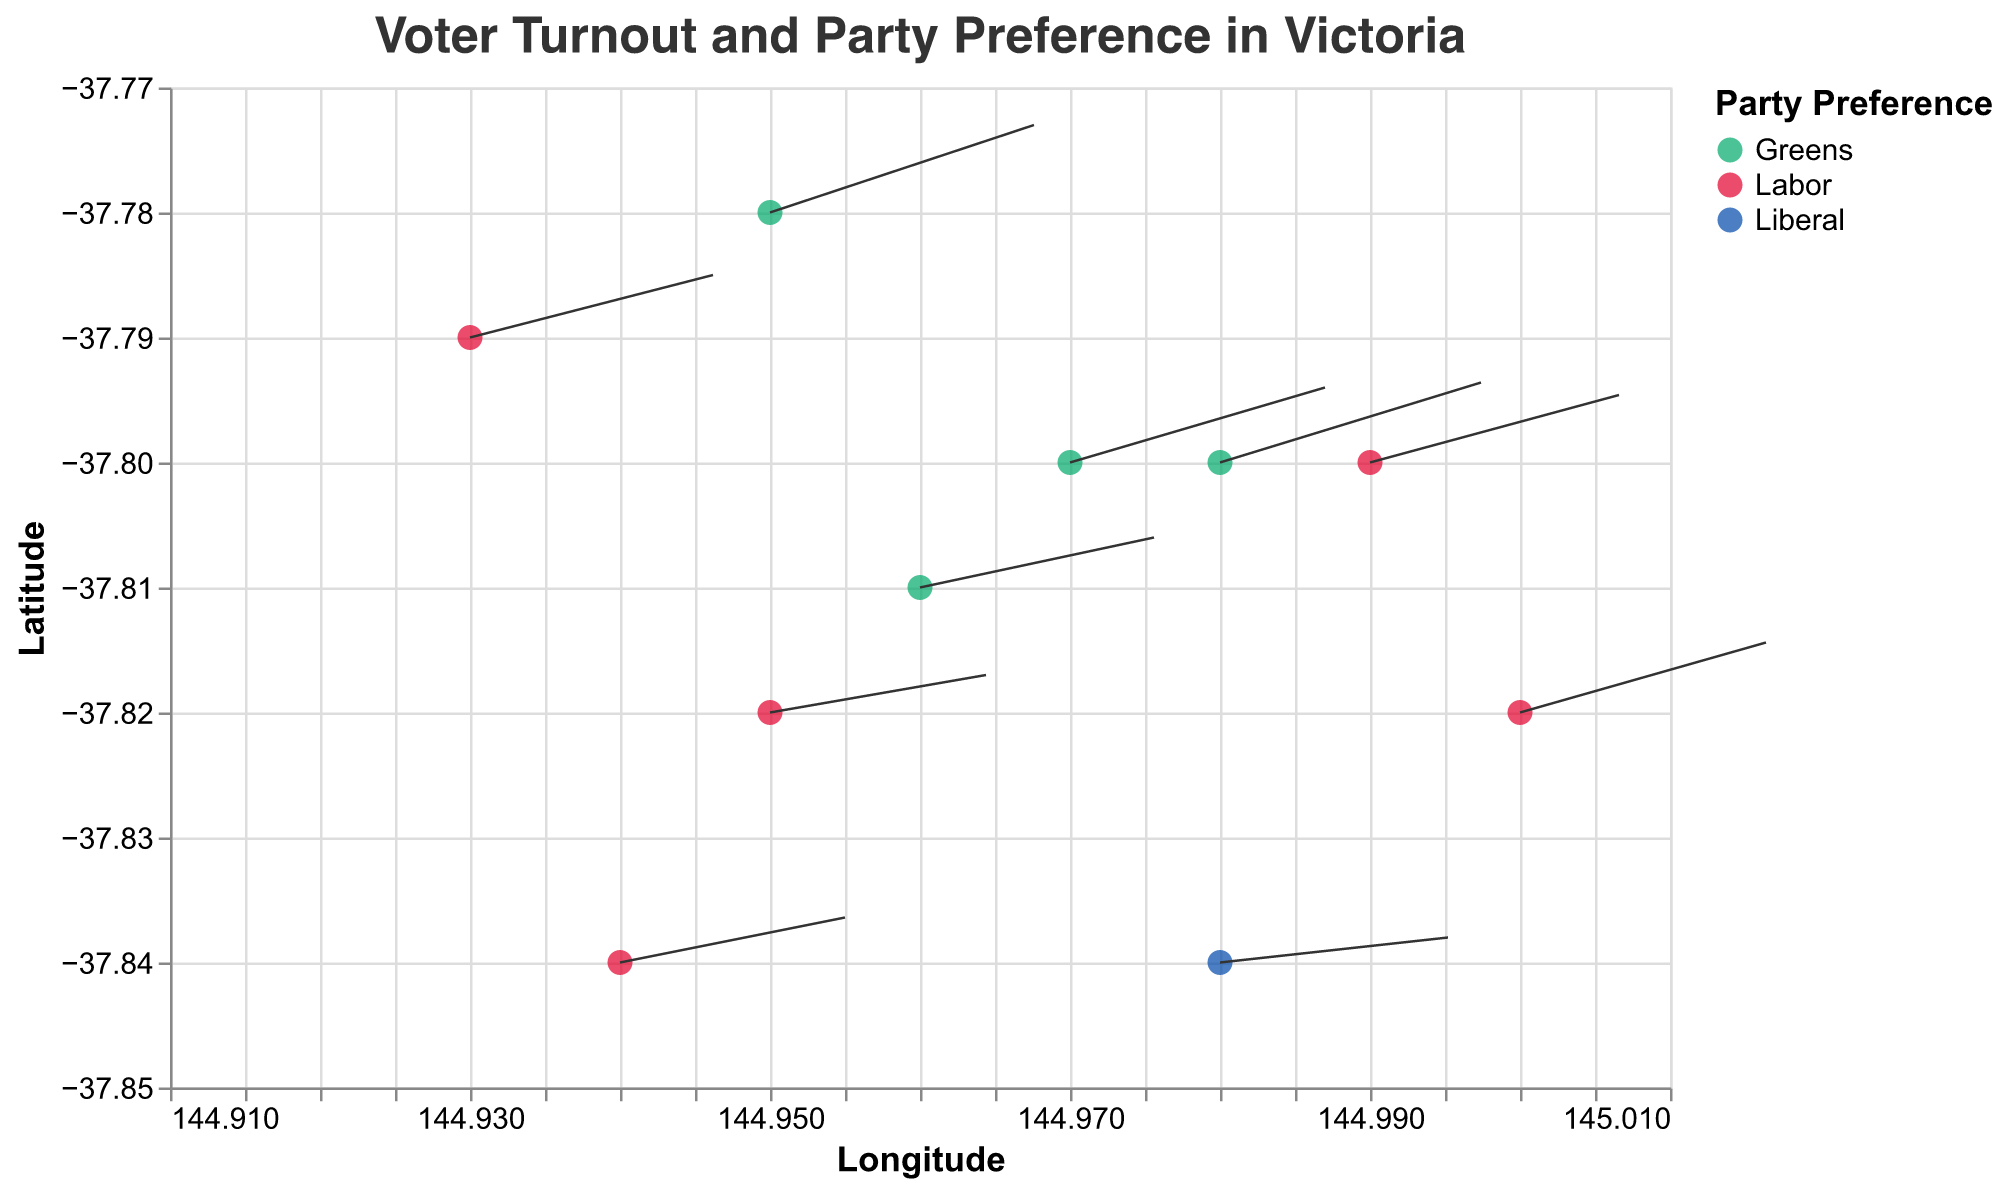What is the title of the figure? The title is typically found at the top of the figure and provides a succinct description of what the visualization is about. In this case, the title is "Voter Turnout and Party Preference in Victoria".
Answer: Voter Turnout and Party Preference in Victoria How many wards are represented in the figure? Counting the number of unique data points plotted on the figure based on their positions will give the number of wards. Here, we have data for ten wards.
Answer: 10 Which party has the highest number of wards with a strong preference in the plot? By observing the color-coded points, we notice that each point represents party preference. Greens are represented by green, Labor by red, and Liberal by blue. By counting the points, we see that the Greens have the most points.
Answer: Greens Which ward has the highest voter turnout vector? The voter turnout vector is visualized by the length of the line extending from the point. From the data, Parkville has the highest turnout vector of 0.88.
Answer: Parkville What is the general location (quadrant) where the Labor party has most of its preferences? To identify the general location, look at the spatial distribution of the red points, representing Labor. These points are clustered around the southern and western parts of the plot, indicating this is where the Labor party is more prevalent.
Answer: Southern and Western Compare the preference vectors between Greens and Labor wards. Who generally has higher preference vectors? By comparing the length of the vectors extending from each party's data points, we can determine that Greens have longer preference vectors in general compared to Labor.
Answer: Greens In which ward do voters have the lowest turnout vector? By analyzing the lengths of the vectors, the shortest one represents the lowest turnout. South Yarra has the lowest turnout vector at 0.76.
Answer: South Yarra Which party has the lowest overall voter turnout vectors? By observing the lengths of the vectors corresponding to each party, Liberal's single point in South Yarra has the shortest vector, indicating they have the lowest overall turnout on average.
Answer: Liberal How do the voter turnout vectors and preference vectors correlate? Observing the figure, when the voter turnout vector length is longer, the preference vectors' lengths tend to also be longer. Hence, there appears to be a positive correlation between voter turnout and preference vectors.
Answer: Positive correlation Which ward has the most balanced voter turnout and preference vector lengths? The "most balanced" would imply relatively equal lengths. Observing the vectors, Melbourne City has comparatively balanced lengths of voter turnout (0.78) and preference (0.2).
Answer: Melbourne City 